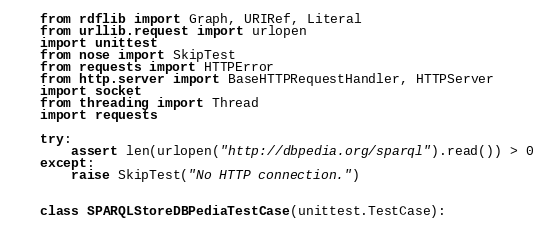Convert code to text. <code><loc_0><loc_0><loc_500><loc_500><_Python_>from rdflib import Graph, URIRef, Literal
from urllib.request import urlopen
import unittest
from nose import SkipTest
from requests import HTTPError
from http.server import BaseHTTPRequestHandler, HTTPServer
import socket
from threading import Thread
import requests

try:
    assert len(urlopen("http://dbpedia.org/sparql").read()) > 0
except:
    raise SkipTest("No HTTP connection.")


class SPARQLStoreDBPediaTestCase(unittest.TestCase):</code> 